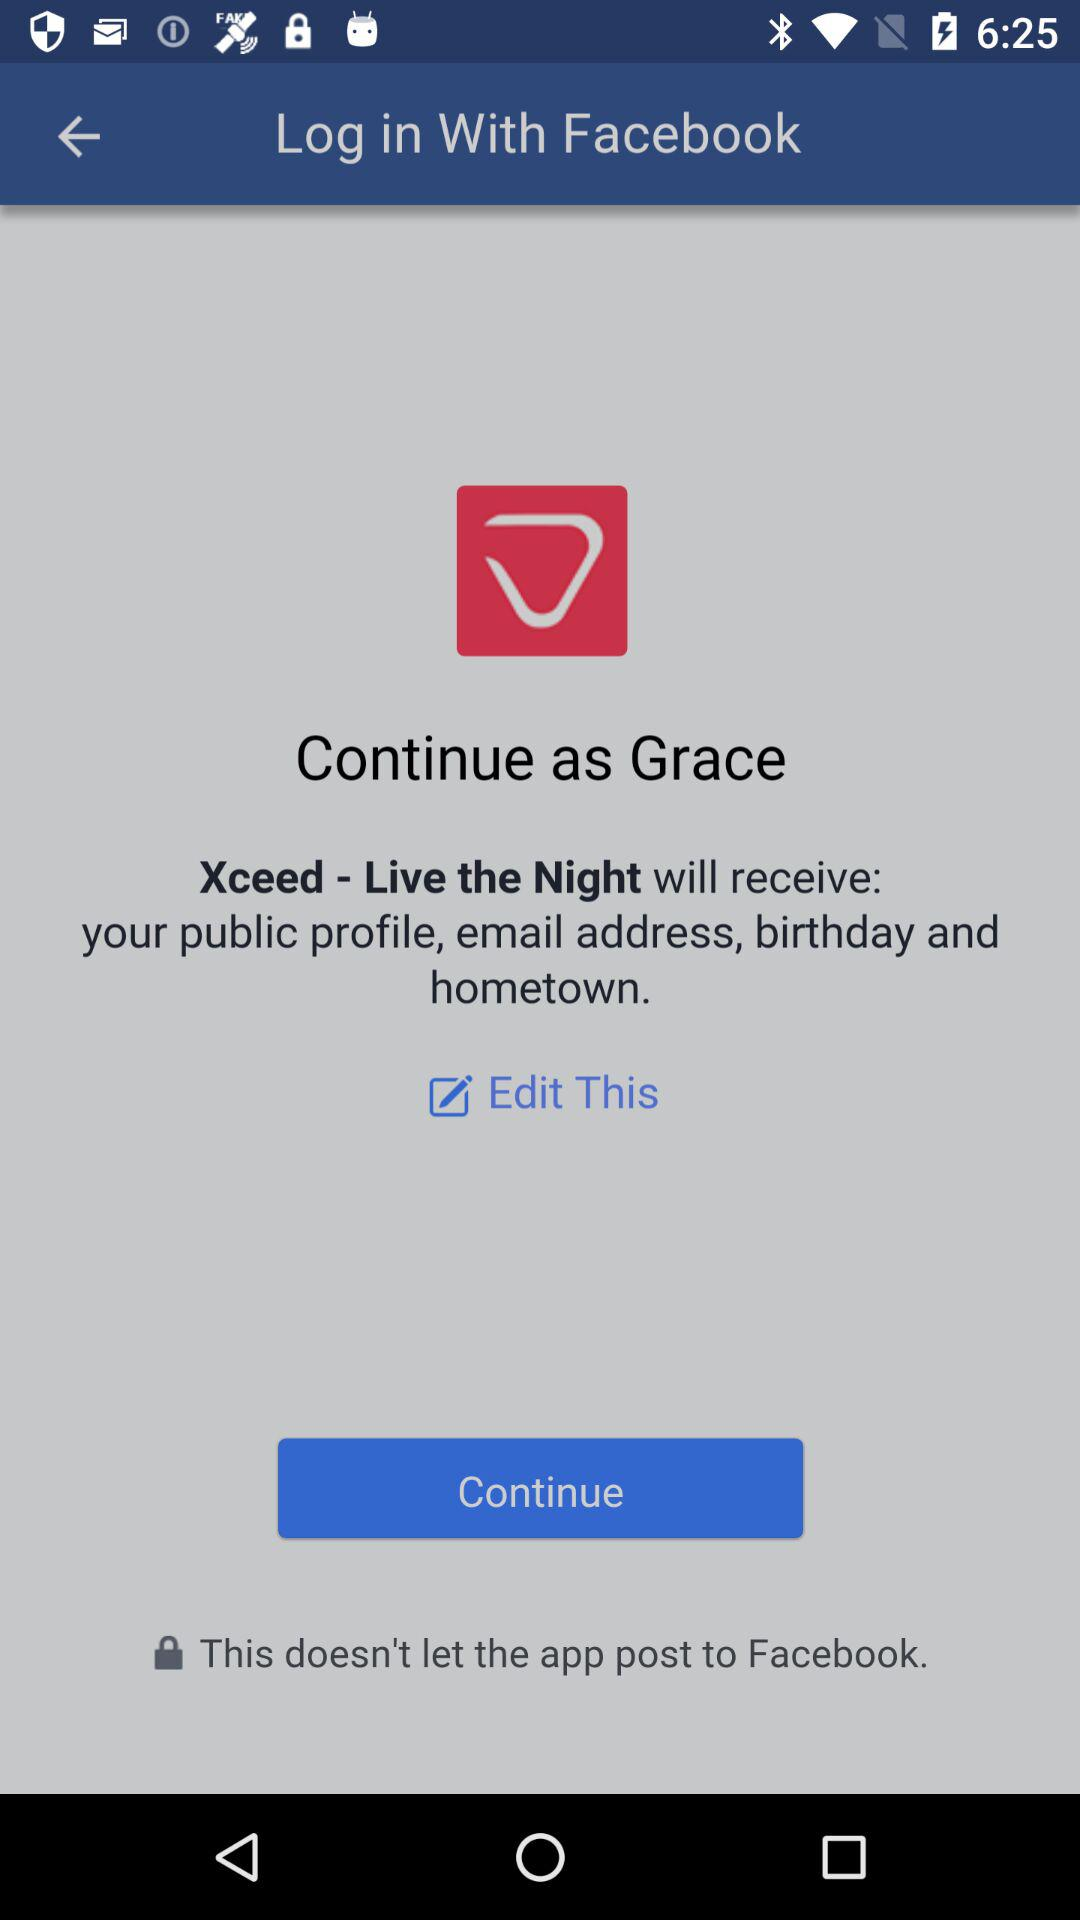What is the user name? The user name is Grace. 